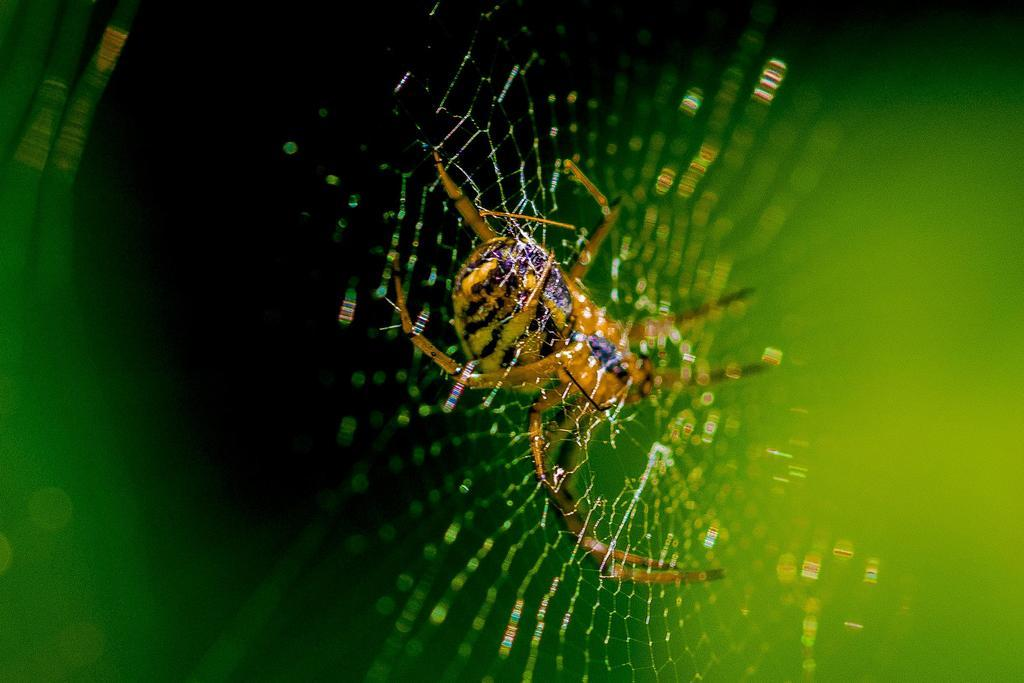What is the main subject of the image? The main subject of the image is a spider. What is the spider associated with in the image? There is a web in the image, which is associated with the spider. What type of bed does the grandfather sleep on in the image? There is no grandfather or bed present in the image; it only features a spider and a web. 